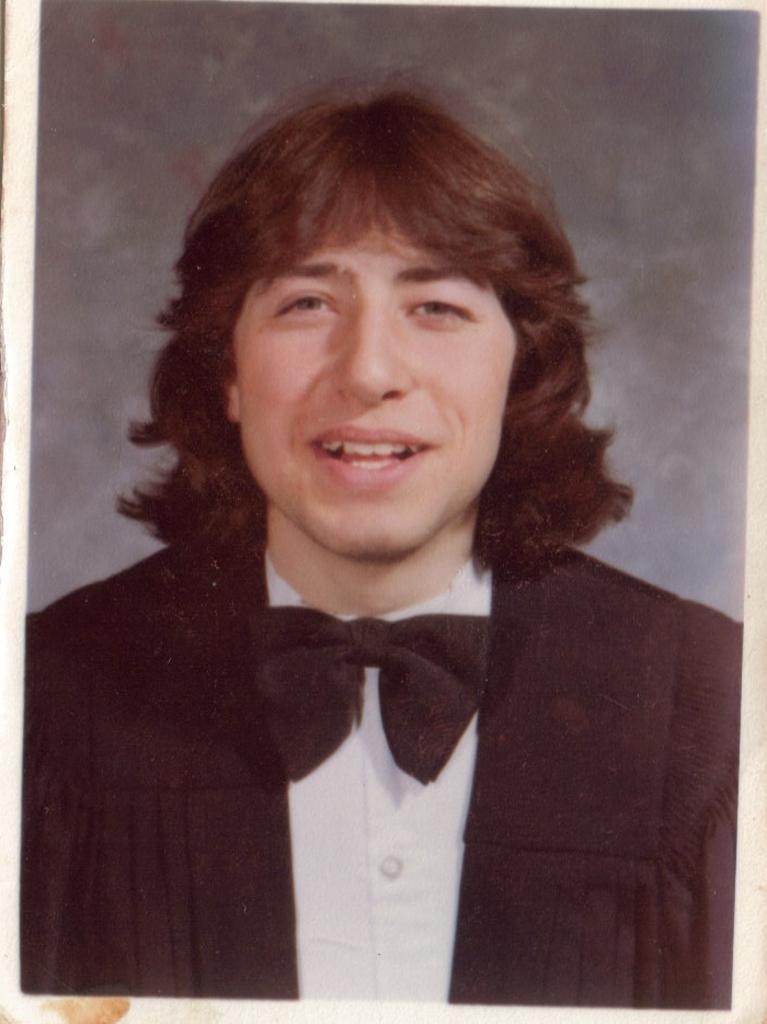Describe this image in one or two sentences. In the picture I can see one person photo. 